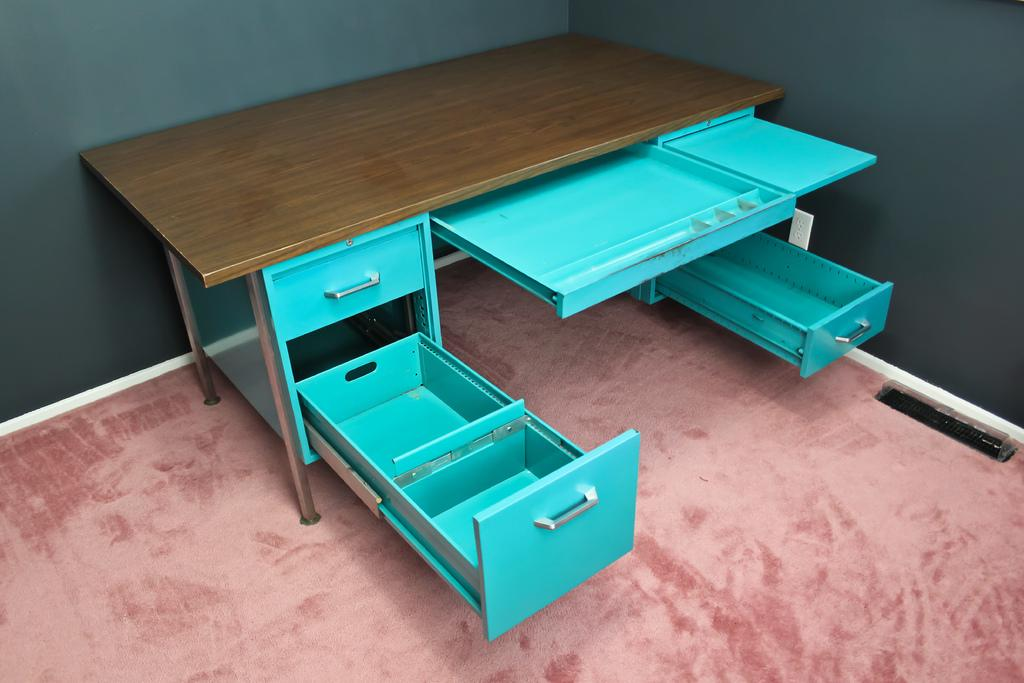What color is the table in the image? The table in the image is brown. What other furniture piece can be seen in the image? There is a blue rack in the image. What color is the carpet in the image? The carpet in the image is pink. What color are the walls in the image? The walls in the image are grey. Can you see the moon in the image? No, the moon is not present in the image. What type of machine is being used for growth in the image? There is no machine or growth-related activity depicted in the image. 